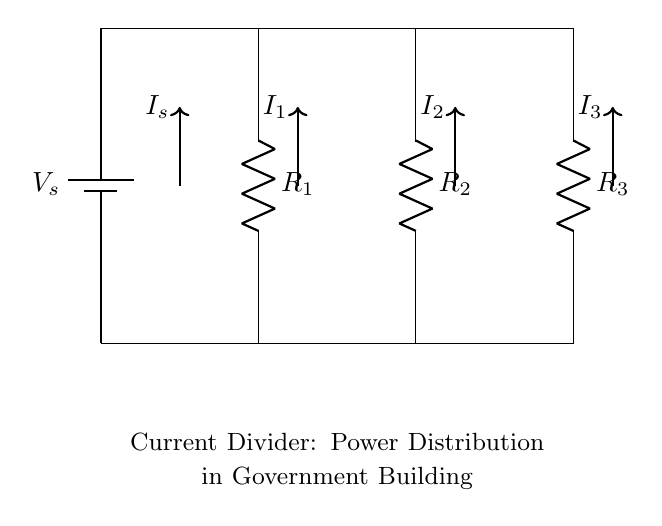What is the source voltage of the circuit? The voltage source, labeled as V_s, provides the total voltage for the circuit. While the specific value is not provided in the diagram, it is clearly indicated as V_s.
Answer: V_s How many resistors are present in the circuit? The circuit diagram shows three resistors connected in parallel, labeled as R_1, R_2, and R_3. Counting them gives a total of three resistors.
Answer: 3 What is the relationship between the currents I_s, I_1, I_2, and I_3? In a current divider circuit, the total current I_s is divided among the resistors. The currents I_1, I_2, and I_3 are the individual currents flowing through each resistor, and together they sum to the source current I_s.
Answer: I_s = I_1 + I_2 + I_3 Which resistor has the highest current passing through it? In a current divider, the resistor with the lowest resistance will have the highest current. Since the values of R_1, R_2, and R_3 are not provided, we cannot definitively determine which resistor will have the highest current based solely on the circuit diagram. The specific current for each resistor would depend on their resistance values.
Answer: Depends on values What type of circuit configuration is depicted in the diagram? The circuit is a parallel configuration, as indicated by the resistors connected across the same voltage source. In parallel circuits, the voltage across each component is the same, and this allows for a current divider effect.
Answer: Parallel circuit If R_1, R_2, and R_3 are equal, how does the current divide? If the resistors are equal, the total current will be evenly divided among them. Therefore, each resistor would carry one-third of the total current. This divides the source current equally as each branch has the same resistance, leading to identical current values for I_1, I_2, and I_3.
Answer: Evenly divided 